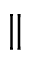<formula> <loc_0><loc_0><loc_500><loc_500>\|</formula> 